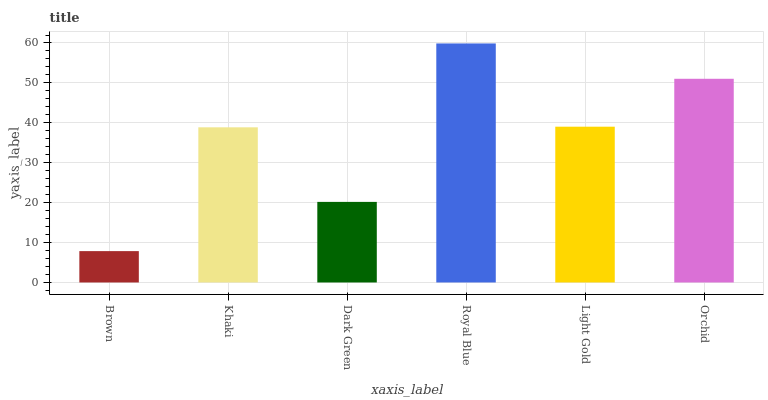Is Brown the minimum?
Answer yes or no. Yes. Is Royal Blue the maximum?
Answer yes or no. Yes. Is Khaki the minimum?
Answer yes or no. No. Is Khaki the maximum?
Answer yes or no. No. Is Khaki greater than Brown?
Answer yes or no. Yes. Is Brown less than Khaki?
Answer yes or no. Yes. Is Brown greater than Khaki?
Answer yes or no. No. Is Khaki less than Brown?
Answer yes or no. No. Is Light Gold the high median?
Answer yes or no. Yes. Is Khaki the low median?
Answer yes or no. Yes. Is Khaki the high median?
Answer yes or no. No. Is Light Gold the low median?
Answer yes or no. No. 